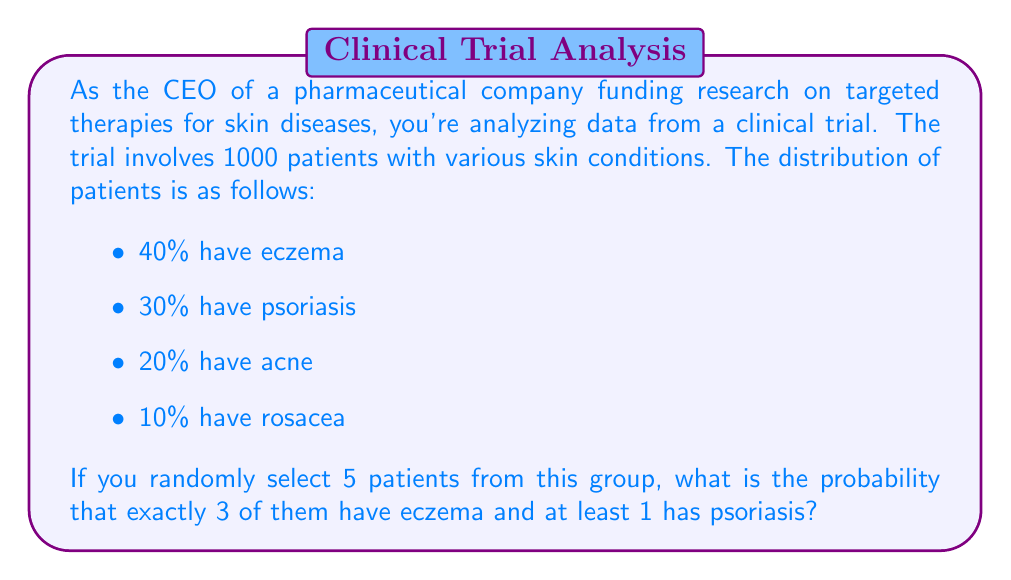Could you help me with this problem? To solve this problem, we'll use the concept of probability and combinations. Let's break it down step-by-step:

1) First, we need to calculate the probability of selecting exactly 3 patients with eczema out of 5:

   $P(\text{3 eczema}) = \binom{5}{3} \cdot 0.4^3 \cdot 0.6^2$

   Where $\binom{5}{3}$ is the number of ways to choose 3 out of 5, 0.4 is the probability of having eczema, and 0.6 is the probability of not having eczema.

2) Next, we need to calculate the probability of having at least 1 psoriasis patient out of the remaining 2:

   $P(\text{at least 1 psoriasis out of 2}) = 1 - P(\text{no psoriasis out of 2})$
   $= 1 - 0.7^2 = 1 - 0.49 = 0.51$

   Where 0.7 is the probability of not having psoriasis.

3) Now, let's calculate each part:

   $\binom{5}{3} = \frac{5!}{3!(5-3)!} = \frac{5 \cdot 4}{2 \cdot 1} = 10$

   $P(\text{3 eczema}) = 10 \cdot 0.4^3 \cdot 0.6^2 = 10 \cdot 0.064 \cdot 0.36 = 0.2304$

4) The final probability is the product of these two probabilities:

   $P(\text{3 eczema and at least 1 psoriasis}) = 0.2304 \cdot 0.51 = 0.11750$
Answer: The probability of randomly selecting exactly 3 patients with eczema and at least 1 with psoriasis out of 5 patients is approximately 0.11750 or 11.75%. 